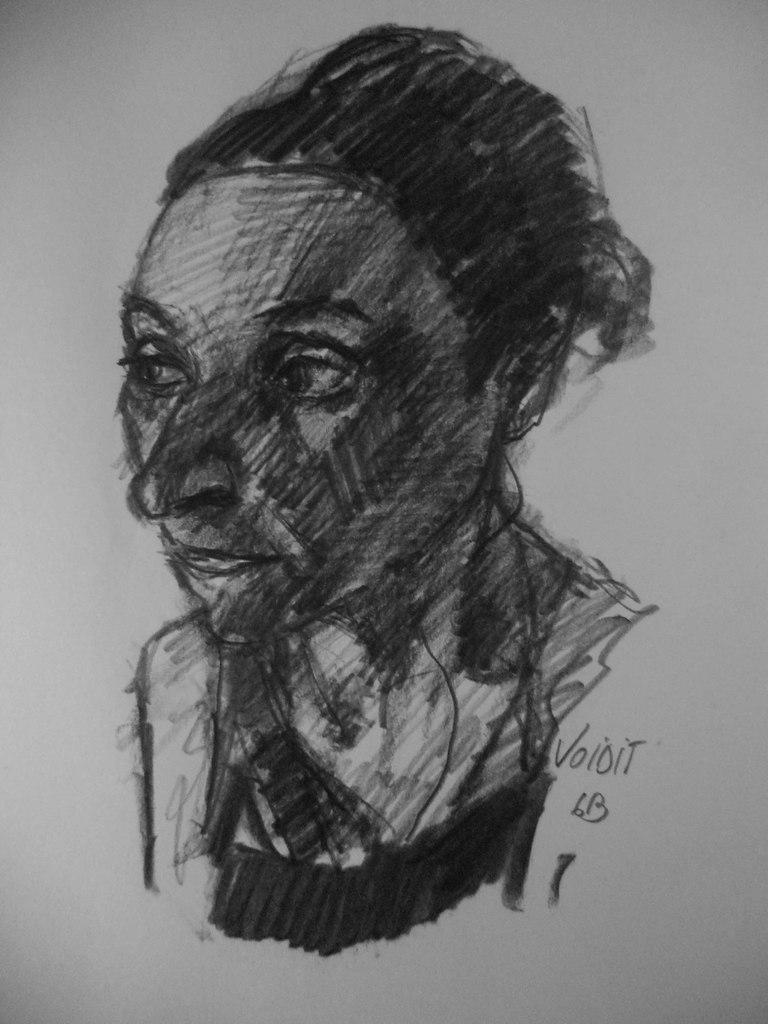What is the main subject of the image? The main subject of the image is a sketch of a person. What is located beside the sketch? There is text beside the sketch. What type of meat is being prepared by the person in the image? There is no person or meat present in the image; it only contains a sketch of a person and accompanying text. 